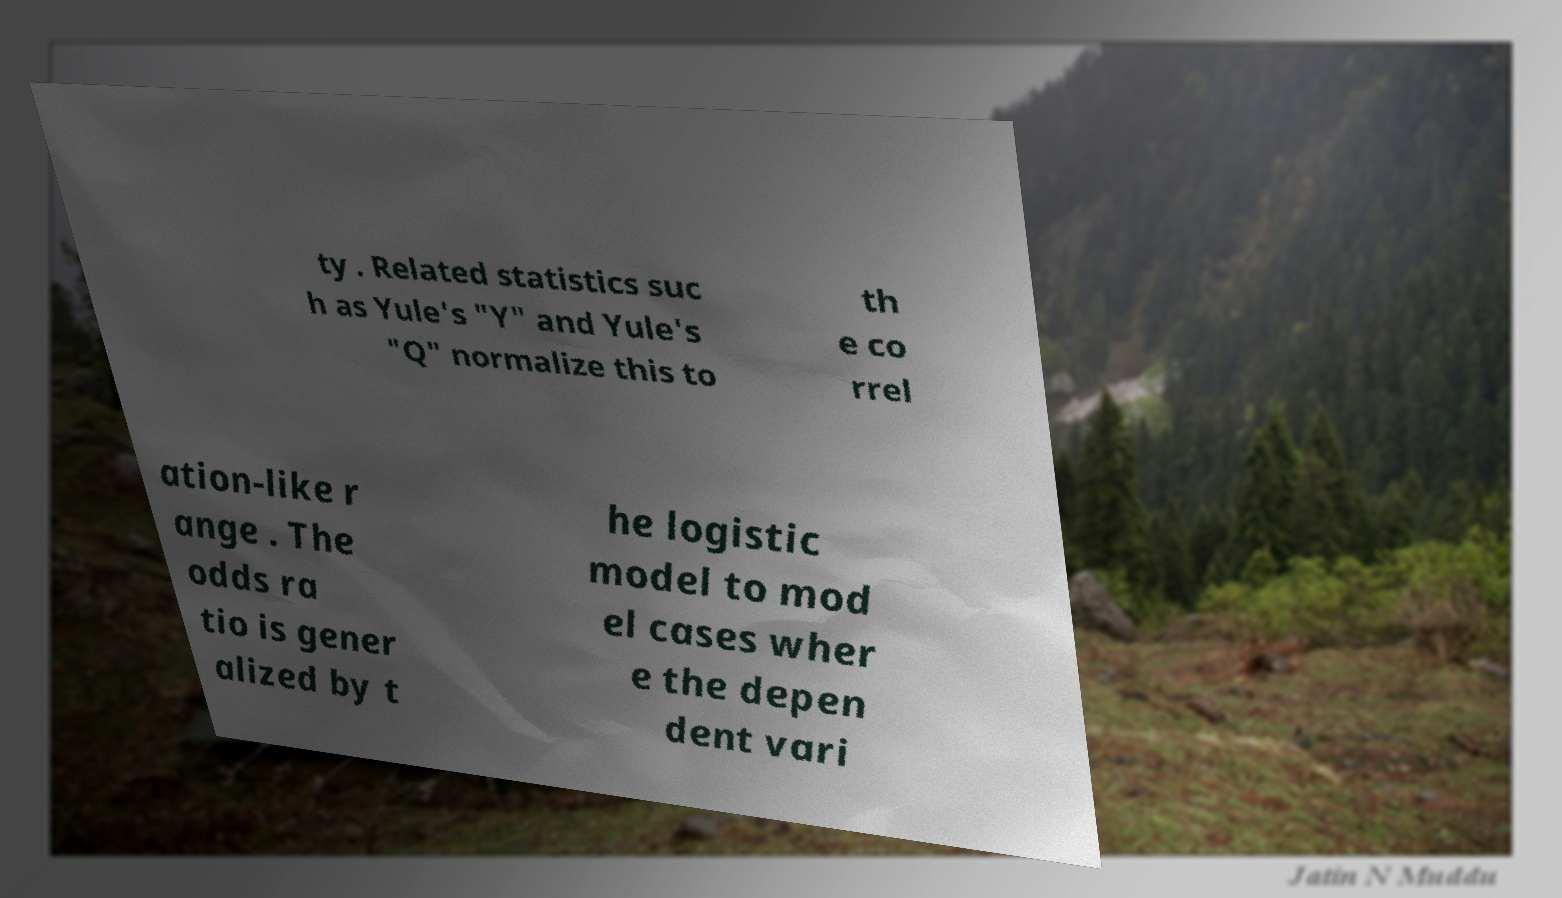Could you assist in decoding the text presented in this image and type it out clearly? ty . Related statistics suc h as Yule's "Y" and Yule's "Q" normalize this to th e co rrel ation-like r ange . The odds ra tio is gener alized by t he logistic model to mod el cases wher e the depen dent vari 